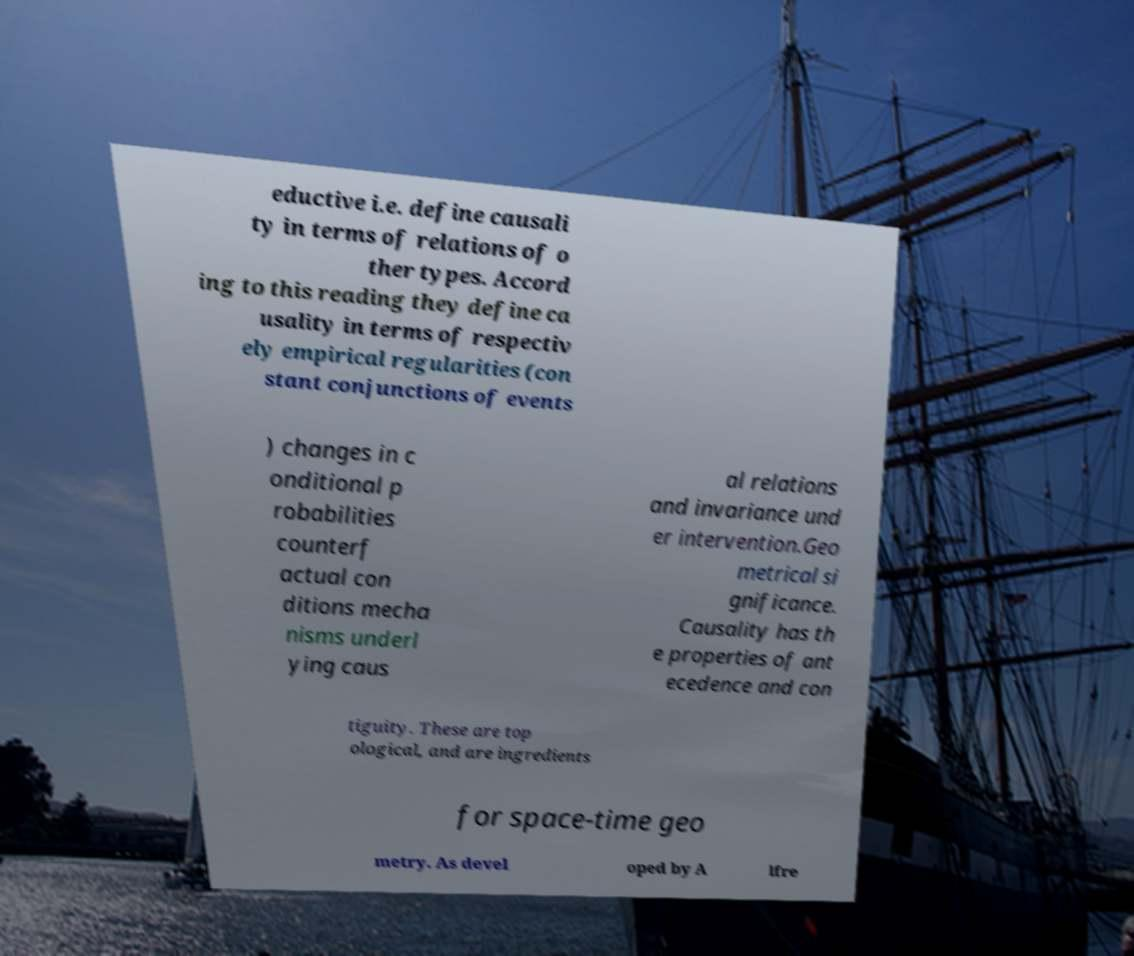Could you assist in decoding the text presented in this image and type it out clearly? eductive i.e. define causali ty in terms of relations of o ther types. Accord ing to this reading they define ca usality in terms of respectiv ely empirical regularities (con stant conjunctions of events ) changes in c onditional p robabilities counterf actual con ditions mecha nisms underl ying caus al relations and invariance und er intervention.Geo metrical si gnificance. Causality has th e properties of ant ecedence and con tiguity. These are top ological, and are ingredients for space-time geo metry. As devel oped by A lfre 